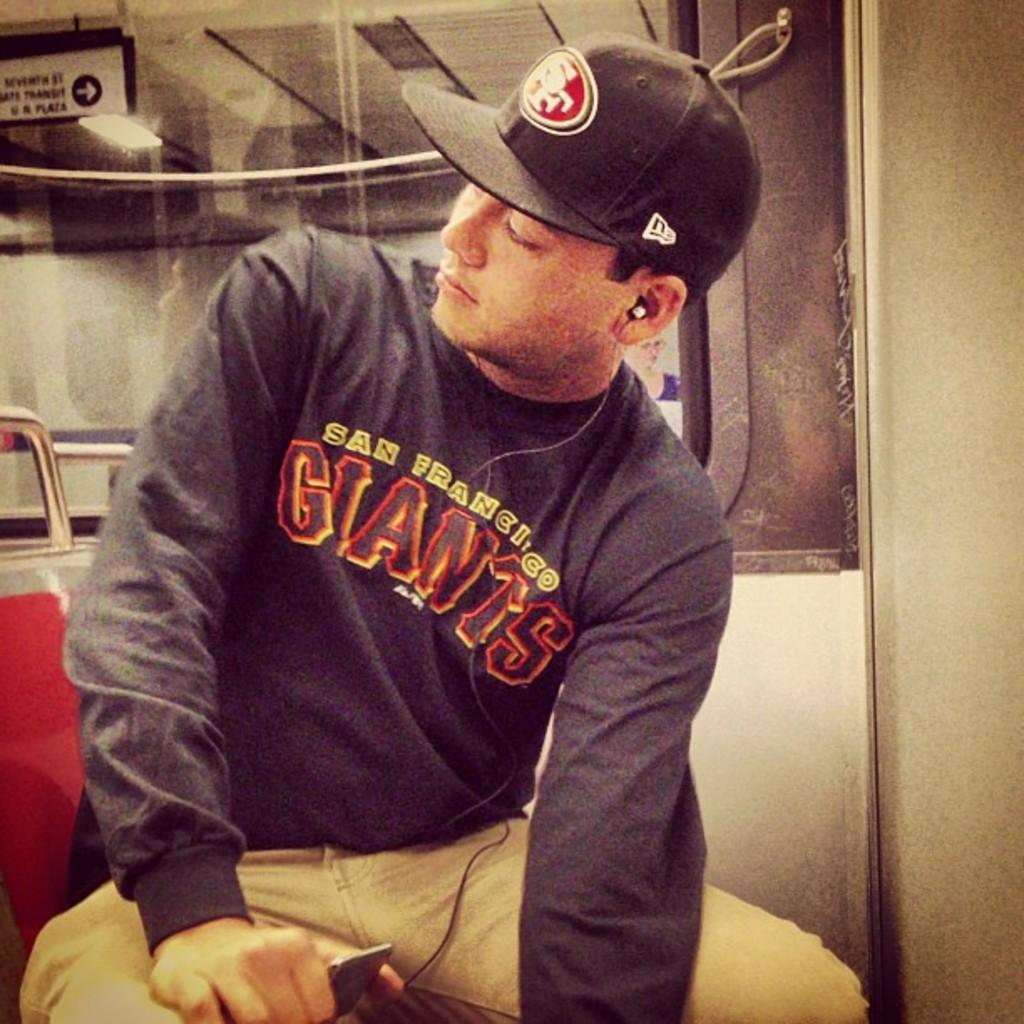<image>
Describe the image concisely. A man wearing a long sleeved tshirt that sasys San Fransisco Giants on it. 